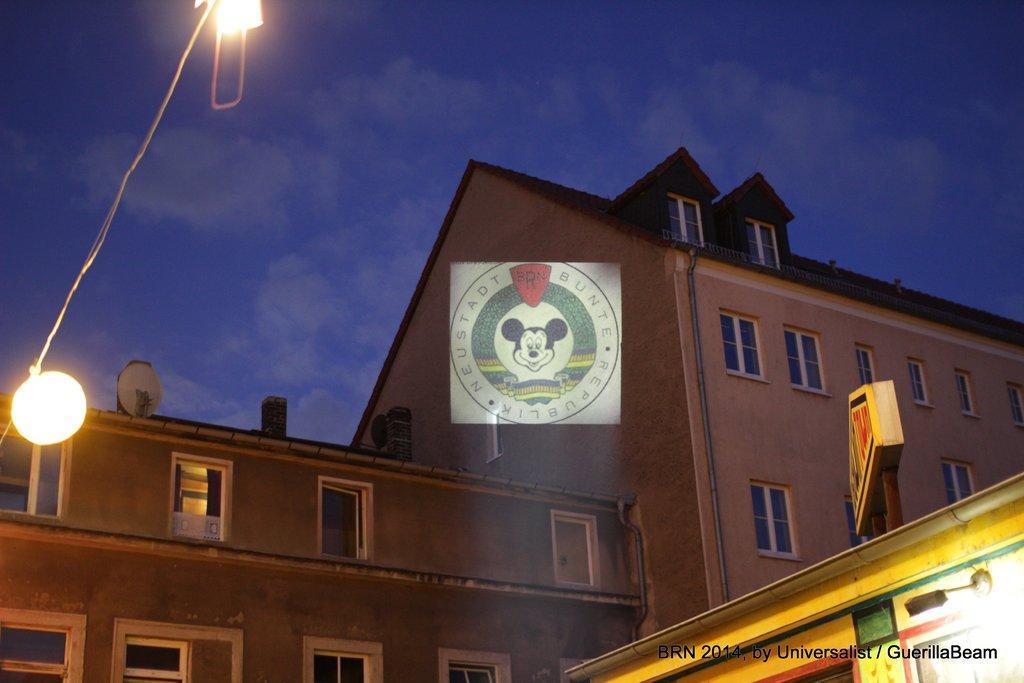Please provide a concise description of this image. In this picture I can see two buildings, there are lights, a board, it is looking like a laser light on the wall, and in the background there is sky and there is a watermark on the image. 